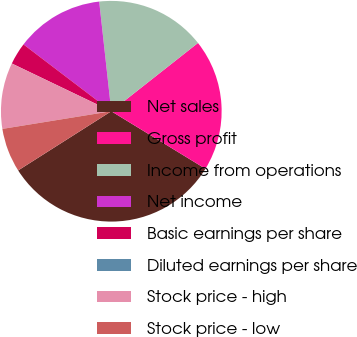Convert chart to OTSL. <chart><loc_0><loc_0><loc_500><loc_500><pie_chart><fcel>Net sales<fcel>Gross profit<fcel>Income from operations<fcel>Net income<fcel>Basic earnings per share<fcel>Diluted earnings per share<fcel>Stock price - high<fcel>Stock price - low<nl><fcel>32.26%<fcel>19.35%<fcel>16.13%<fcel>12.9%<fcel>3.23%<fcel>0.0%<fcel>9.68%<fcel>6.45%<nl></chart> 